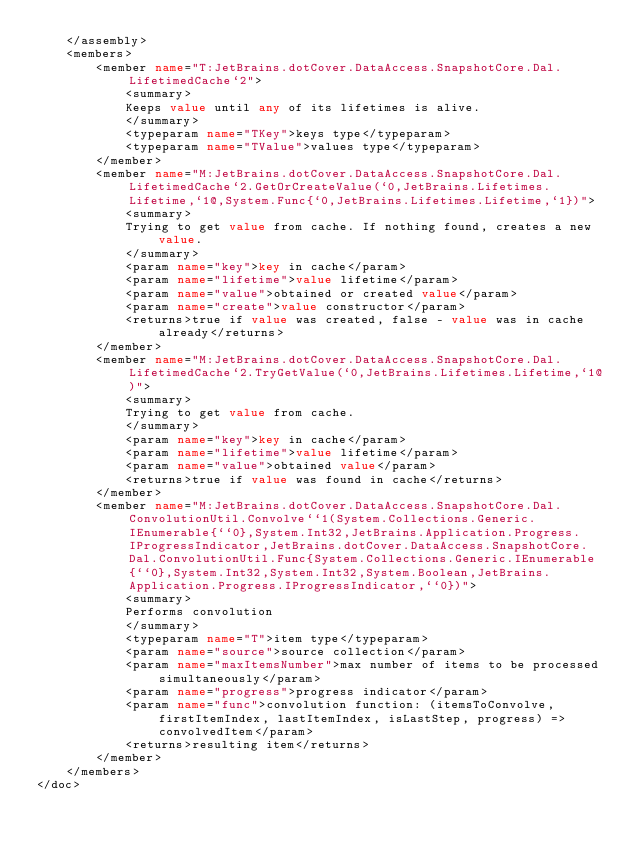<code> <loc_0><loc_0><loc_500><loc_500><_XML_>    </assembly>
    <members>
        <member name="T:JetBrains.dotCover.DataAccess.SnapshotCore.Dal.LifetimedCache`2">
            <summary>
            Keeps value until any of its lifetimes is alive.
            </summary>
            <typeparam name="TKey">keys type</typeparam>
            <typeparam name="TValue">values type</typeparam>
        </member>
        <member name="M:JetBrains.dotCover.DataAccess.SnapshotCore.Dal.LifetimedCache`2.GetOrCreateValue(`0,JetBrains.Lifetimes.Lifetime,`1@,System.Func{`0,JetBrains.Lifetimes.Lifetime,`1})">
            <summary>
            Trying to get value from cache. If nothing found, creates a new value.  
            </summary>
            <param name="key">key in cache</param>
            <param name="lifetime">value lifetime</param>
            <param name="value">obtained or created value</param>
            <param name="create">value constructor</param>
            <returns>true if value was created, false - value was in cache already</returns>
        </member>
        <member name="M:JetBrains.dotCover.DataAccess.SnapshotCore.Dal.LifetimedCache`2.TryGetValue(`0,JetBrains.Lifetimes.Lifetime,`1@)">
            <summary>
            Trying to get value from cache.
            </summary>
            <param name="key">key in cache</param>
            <param name="lifetime">value lifetime</param>
            <param name="value">obtained value</param>
            <returns>true if value was found in cache</returns>
        </member>
        <member name="M:JetBrains.dotCover.DataAccess.SnapshotCore.Dal.ConvolutionUtil.Convolve``1(System.Collections.Generic.IEnumerable{``0},System.Int32,JetBrains.Application.Progress.IProgressIndicator,JetBrains.dotCover.DataAccess.SnapshotCore.Dal.ConvolutionUtil.Func{System.Collections.Generic.IEnumerable{``0},System.Int32,System.Int32,System.Boolean,JetBrains.Application.Progress.IProgressIndicator,``0})">
            <summary>
            Performs convolution
            </summary>
            <typeparam name="T">item type</typeparam>
            <param name="source">source collection</param>
            <param name="maxItemsNumber">max number of items to be processed simultaneously</param>
            <param name="progress">progress indicator</param>
            <param name="func">convolution function: (itemsToConvolve, firstItemIndex, lastItemIndex, isLastStep, progress) => convolvedItem</param>
            <returns>resulting item</returns>
        </member>
    </members>
</doc>
</code> 